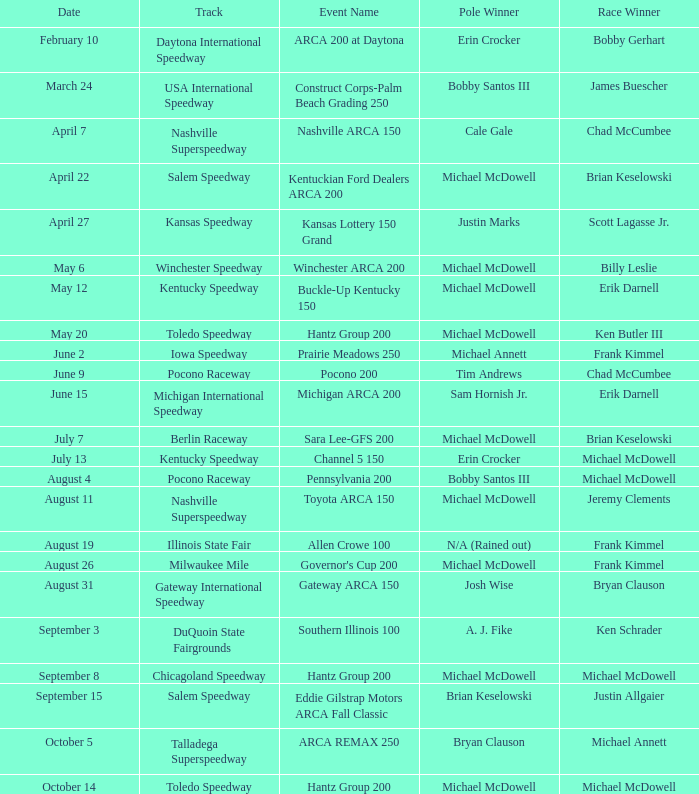Who was the winner of the pole on may 12th? Michael McDowell. 